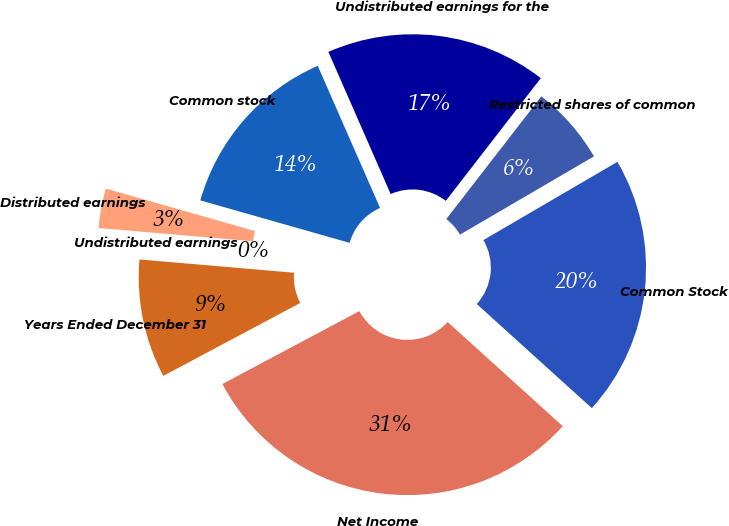Convert chart to OTSL. <chart><loc_0><loc_0><loc_500><loc_500><pie_chart><fcel>Years Ended December 31<fcel>Net Income<fcel>Common Stock<fcel>Restricted shares of common<fcel>Undistributed earnings for the<fcel>Common stock<fcel>Distributed earnings<fcel>Undistributed earnings<nl><fcel>9.15%<fcel>30.5%<fcel>20.12%<fcel>6.1%<fcel>17.06%<fcel>14.01%<fcel>3.05%<fcel>0.0%<nl></chart> 